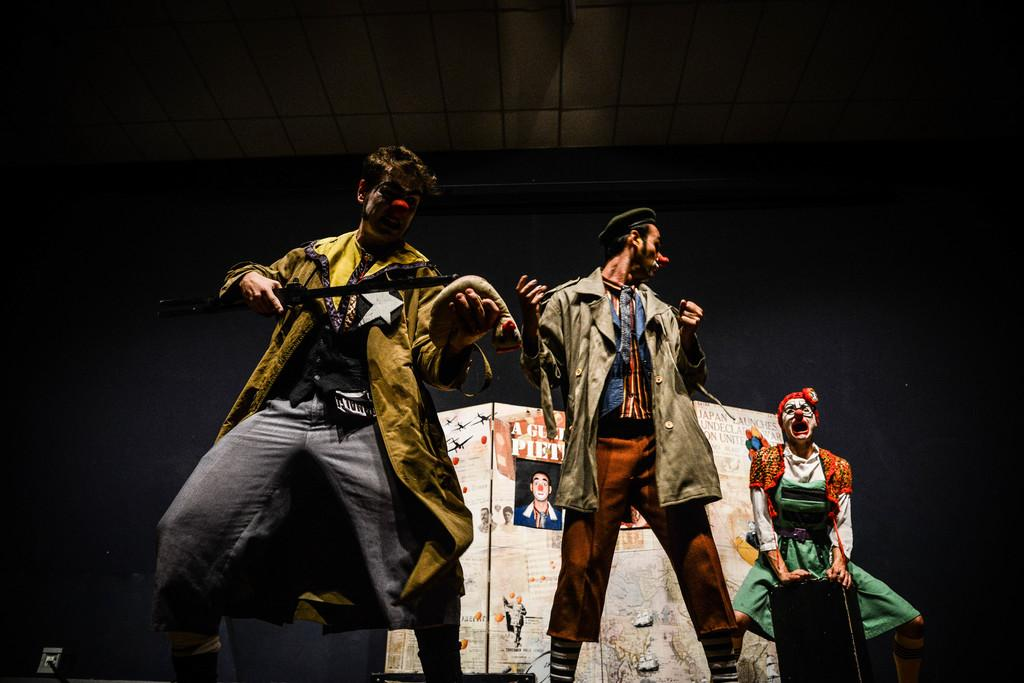How many people are in the image? There are three persons in the image. What are the persons wearing? The persons are wearing fancy dresses. What are the persons holding in the image? The persons are holding objects. What can be seen in the background of the image? There is a board with letters and photos in the background of the image. What type of winter activity is the person in the middle participating in? There is no indication of winter or any winter activity in the image. 